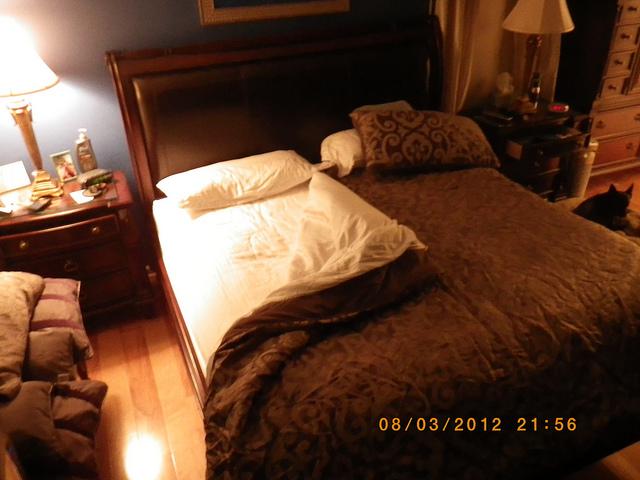What date was this picture taken?
Be succinct. 08/03/2012. Is someone getting ready for bed?
Concise answer only. Yes. How many lamps are visible?
Keep it brief. 2. 